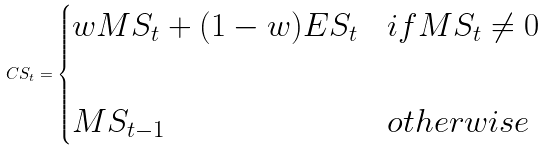<formula> <loc_0><loc_0><loc_500><loc_500>C S _ { t } = \begin{cases} w M S _ { t } + ( 1 - w ) E S _ { t } & i f M S _ { t } \neq 0 \\ \\ M S _ { t - 1 } & o t h e r w i s e \end{cases}</formula> 